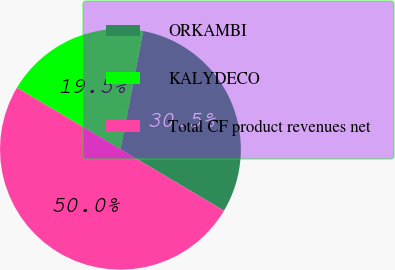Convert chart to OTSL. <chart><loc_0><loc_0><loc_500><loc_500><pie_chart><fcel>ORKAMBI<fcel>KALYDECO<fcel>Total CF product revenues net<nl><fcel>30.5%<fcel>19.5%<fcel>50.0%<nl></chart> 